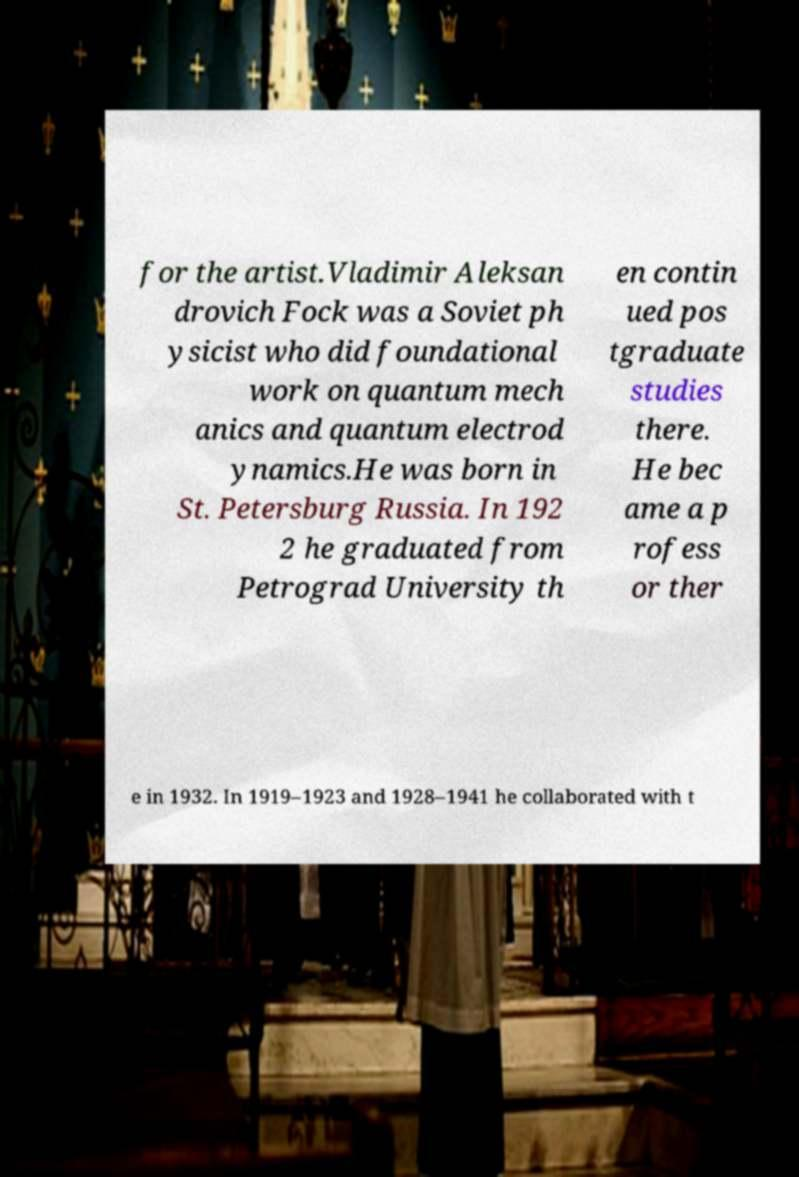I need the written content from this picture converted into text. Can you do that? for the artist.Vladimir Aleksan drovich Fock was a Soviet ph ysicist who did foundational work on quantum mech anics and quantum electrod ynamics.He was born in St. Petersburg Russia. In 192 2 he graduated from Petrograd University th en contin ued pos tgraduate studies there. He bec ame a p rofess or ther e in 1932. In 1919–1923 and 1928–1941 he collaborated with t 